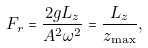Convert formula to latex. <formula><loc_0><loc_0><loc_500><loc_500>F _ { r } = \frac { 2 g L _ { z } } { A ^ { 2 } \omega ^ { 2 } } = \frac { L _ { z } } { z _ { \max } } ,</formula> 